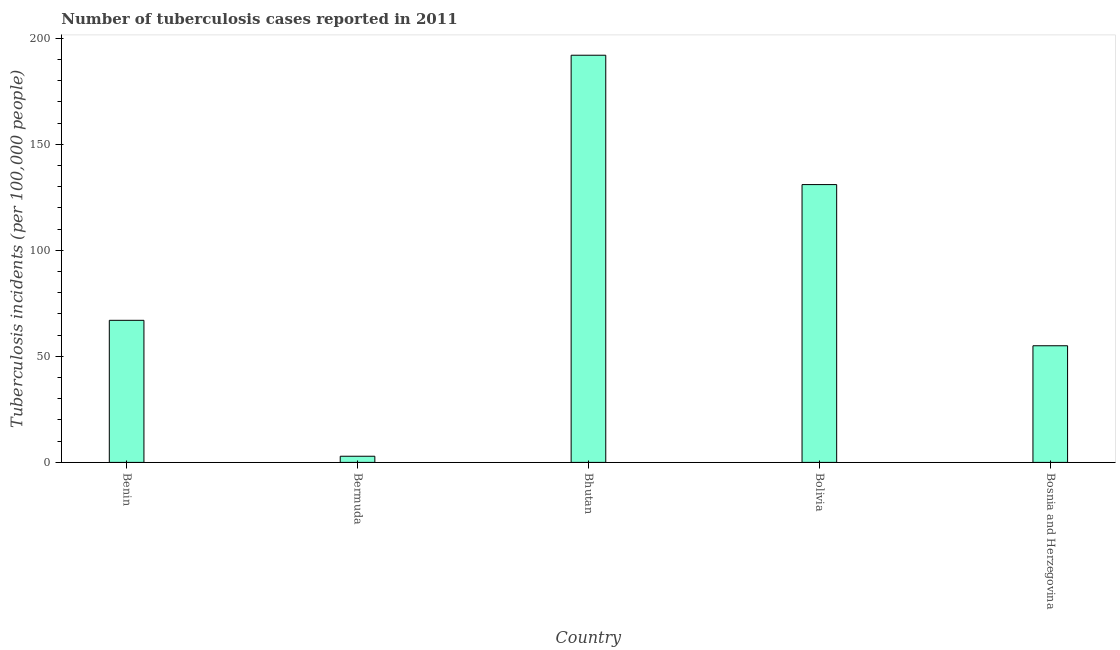Does the graph contain any zero values?
Make the answer very short. No. Does the graph contain grids?
Your response must be concise. No. What is the title of the graph?
Offer a terse response. Number of tuberculosis cases reported in 2011. What is the label or title of the Y-axis?
Ensure brevity in your answer.  Tuberculosis incidents (per 100,0 people). What is the number of tuberculosis incidents in Bosnia and Herzegovina?
Provide a short and direct response. 55. Across all countries, what is the maximum number of tuberculosis incidents?
Provide a succinct answer. 192. In which country was the number of tuberculosis incidents maximum?
Offer a very short reply. Bhutan. In which country was the number of tuberculosis incidents minimum?
Your response must be concise. Bermuda. What is the sum of the number of tuberculosis incidents?
Your response must be concise. 447.9. What is the difference between the number of tuberculosis incidents in Benin and Bhutan?
Provide a short and direct response. -125. What is the average number of tuberculosis incidents per country?
Your answer should be compact. 89.58. What is the median number of tuberculosis incidents?
Offer a terse response. 67. What is the ratio of the number of tuberculosis incidents in Benin to that in Bolivia?
Your response must be concise. 0.51. Is the number of tuberculosis incidents in Benin less than that in Bosnia and Herzegovina?
Give a very brief answer. No. Is the difference between the number of tuberculosis incidents in Benin and Bosnia and Herzegovina greater than the difference between any two countries?
Offer a terse response. No. What is the difference between the highest and the lowest number of tuberculosis incidents?
Your answer should be compact. 189.1. How many bars are there?
Offer a very short reply. 5. What is the difference between two consecutive major ticks on the Y-axis?
Provide a short and direct response. 50. Are the values on the major ticks of Y-axis written in scientific E-notation?
Your response must be concise. No. What is the Tuberculosis incidents (per 100,000 people) of Bhutan?
Offer a very short reply. 192. What is the Tuberculosis incidents (per 100,000 people) in Bolivia?
Provide a short and direct response. 131. What is the Tuberculosis incidents (per 100,000 people) of Bosnia and Herzegovina?
Provide a short and direct response. 55. What is the difference between the Tuberculosis incidents (per 100,000 people) in Benin and Bermuda?
Your answer should be very brief. 64.1. What is the difference between the Tuberculosis incidents (per 100,000 people) in Benin and Bhutan?
Make the answer very short. -125. What is the difference between the Tuberculosis incidents (per 100,000 people) in Benin and Bolivia?
Make the answer very short. -64. What is the difference between the Tuberculosis incidents (per 100,000 people) in Benin and Bosnia and Herzegovina?
Give a very brief answer. 12. What is the difference between the Tuberculosis incidents (per 100,000 people) in Bermuda and Bhutan?
Make the answer very short. -189.1. What is the difference between the Tuberculosis incidents (per 100,000 people) in Bermuda and Bolivia?
Offer a terse response. -128.1. What is the difference between the Tuberculosis incidents (per 100,000 people) in Bermuda and Bosnia and Herzegovina?
Give a very brief answer. -52.1. What is the difference between the Tuberculosis incidents (per 100,000 people) in Bhutan and Bolivia?
Your answer should be very brief. 61. What is the difference between the Tuberculosis incidents (per 100,000 people) in Bhutan and Bosnia and Herzegovina?
Offer a terse response. 137. What is the difference between the Tuberculosis incidents (per 100,000 people) in Bolivia and Bosnia and Herzegovina?
Offer a terse response. 76. What is the ratio of the Tuberculosis incidents (per 100,000 people) in Benin to that in Bermuda?
Your answer should be compact. 23.1. What is the ratio of the Tuberculosis incidents (per 100,000 people) in Benin to that in Bhutan?
Make the answer very short. 0.35. What is the ratio of the Tuberculosis incidents (per 100,000 people) in Benin to that in Bolivia?
Your answer should be compact. 0.51. What is the ratio of the Tuberculosis incidents (per 100,000 people) in Benin to that in Bosnia and Herzegovina?
Make the answer very short. 1.22. What is the ratio of the Tuberculosis incidents (per 100,000 people) in Bermuda to that in Bhutan?
Your answer should be very brief. 0.01. What is the ratio of the Tuberculosis incidents (per 100,000 people) in Bermuda to that in Bolivia?
Ensure brevity in your answer.  0.02. What is the ratio of the Tuberculosis incidents (per 100,000 people) in Bermuda to that in Bosnia and Herzegovina?
Offer a terse response. 0.05. What is the ratio of the Tuberculosis incidents (per 100,000 people) in Bhutan to that in Bolivia?
Your answer should be compact. 1.47. What is the ratio of the Tuberculosis incidents (per 100,000 people) in Bhutan to that in Bosnia and Herzegovina?
Your response must be concise. 3.49. What is the ratio of the Tuberculosis incidents (per 100,000 people) in Bolivia to that in Bosnia and Herzegovina?
Your answer should be very brief. 2.38. 